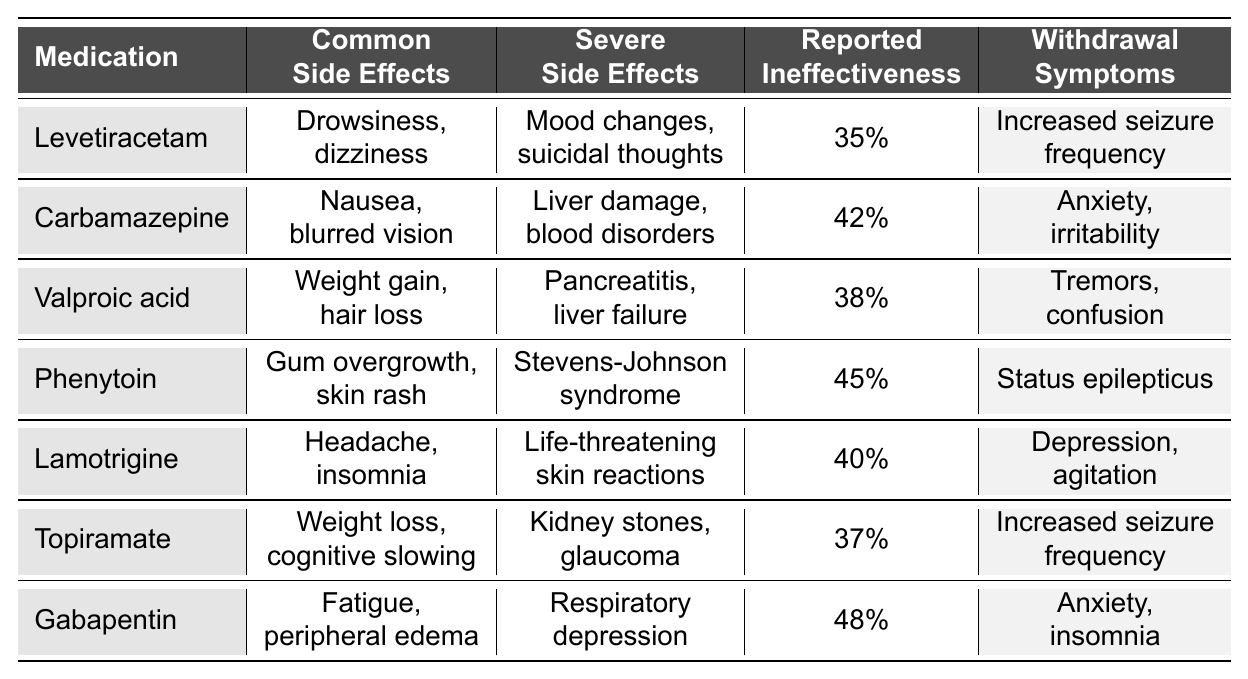What percentage of reported ineffectiveness is associated with Phenytoin? According to the table, Phenytoin has a reported ineffectiveness of 45%.
Answer: 45% Which medication has the most severe side effects listed? The table indicates that Phenytoin has "Stevens-Johnson syndrome," which is considered among the most serious severe side effects, compared to others like liver failure or pancreatitis.
Answer: Phenytoin What are the common side effects of Carbamazepine? The table lists the common side effects of Carbamazepine as "Nausea, blurred vision."
Answer: Nausea, blurred vision Is Gabapentin associated with more severe side effects or common side effects based on the table? Gabapentin has "Respiratory depression" listed as a severe side effect, which is more severe than its common side effects like "Fatigue, peripheral edema." Thus, it leans more towards severe side effects.
Answer: More severe side effects Which medication has the lowest reported ineffectiveness percentage? By checking the reported ineffectiveness percentages, Levetiracetam has the lowest at 35%.
Answer: Levetiracetam What are the withdrawal symptoms for Valproic acid? The withdrawal symptoms associated with Valproic acid are "Tremors, confusion."
Answer: Tremors, confusion How many medications have a reported ineffectiveness of 40% or more? Counting the medications listed: Carbamazepine (42%), Valproic acid (38%), Phenytoin (45%), Lamotrigine (40%), and Gabapentin (48%), we find that there are 5 medications with 40% or more ineffectiveness.
Answer: 5 Among the listed medications, which ones share similar common side effects? Both Levetiracetam and Topiramate share "Drowsiness, dizziness" and "Weight loss, cognitive slowing," but no exact matches in common side effects. Therefore, no common side effects were found.
Answer: No common side effects What percentage is reported for ineffectiveness of Gabapentin and how does it compare to that of Lamotrigine? Gabapentin reports 48% ineffectiveness while Lamotrigine reports 40%. Therefore, Gabapentin has 8% higher ineffectiveness than Lamotrigine.
Answer: Gabapentin is 48% Which medication's withdrawal symptoms include increased seizure frequency? The table indicates that both Levetiracetam and Topiramate have "Increased seizure frequency" as withdrawal symptoms.
Answer: Levetiracetam, Topiramate 